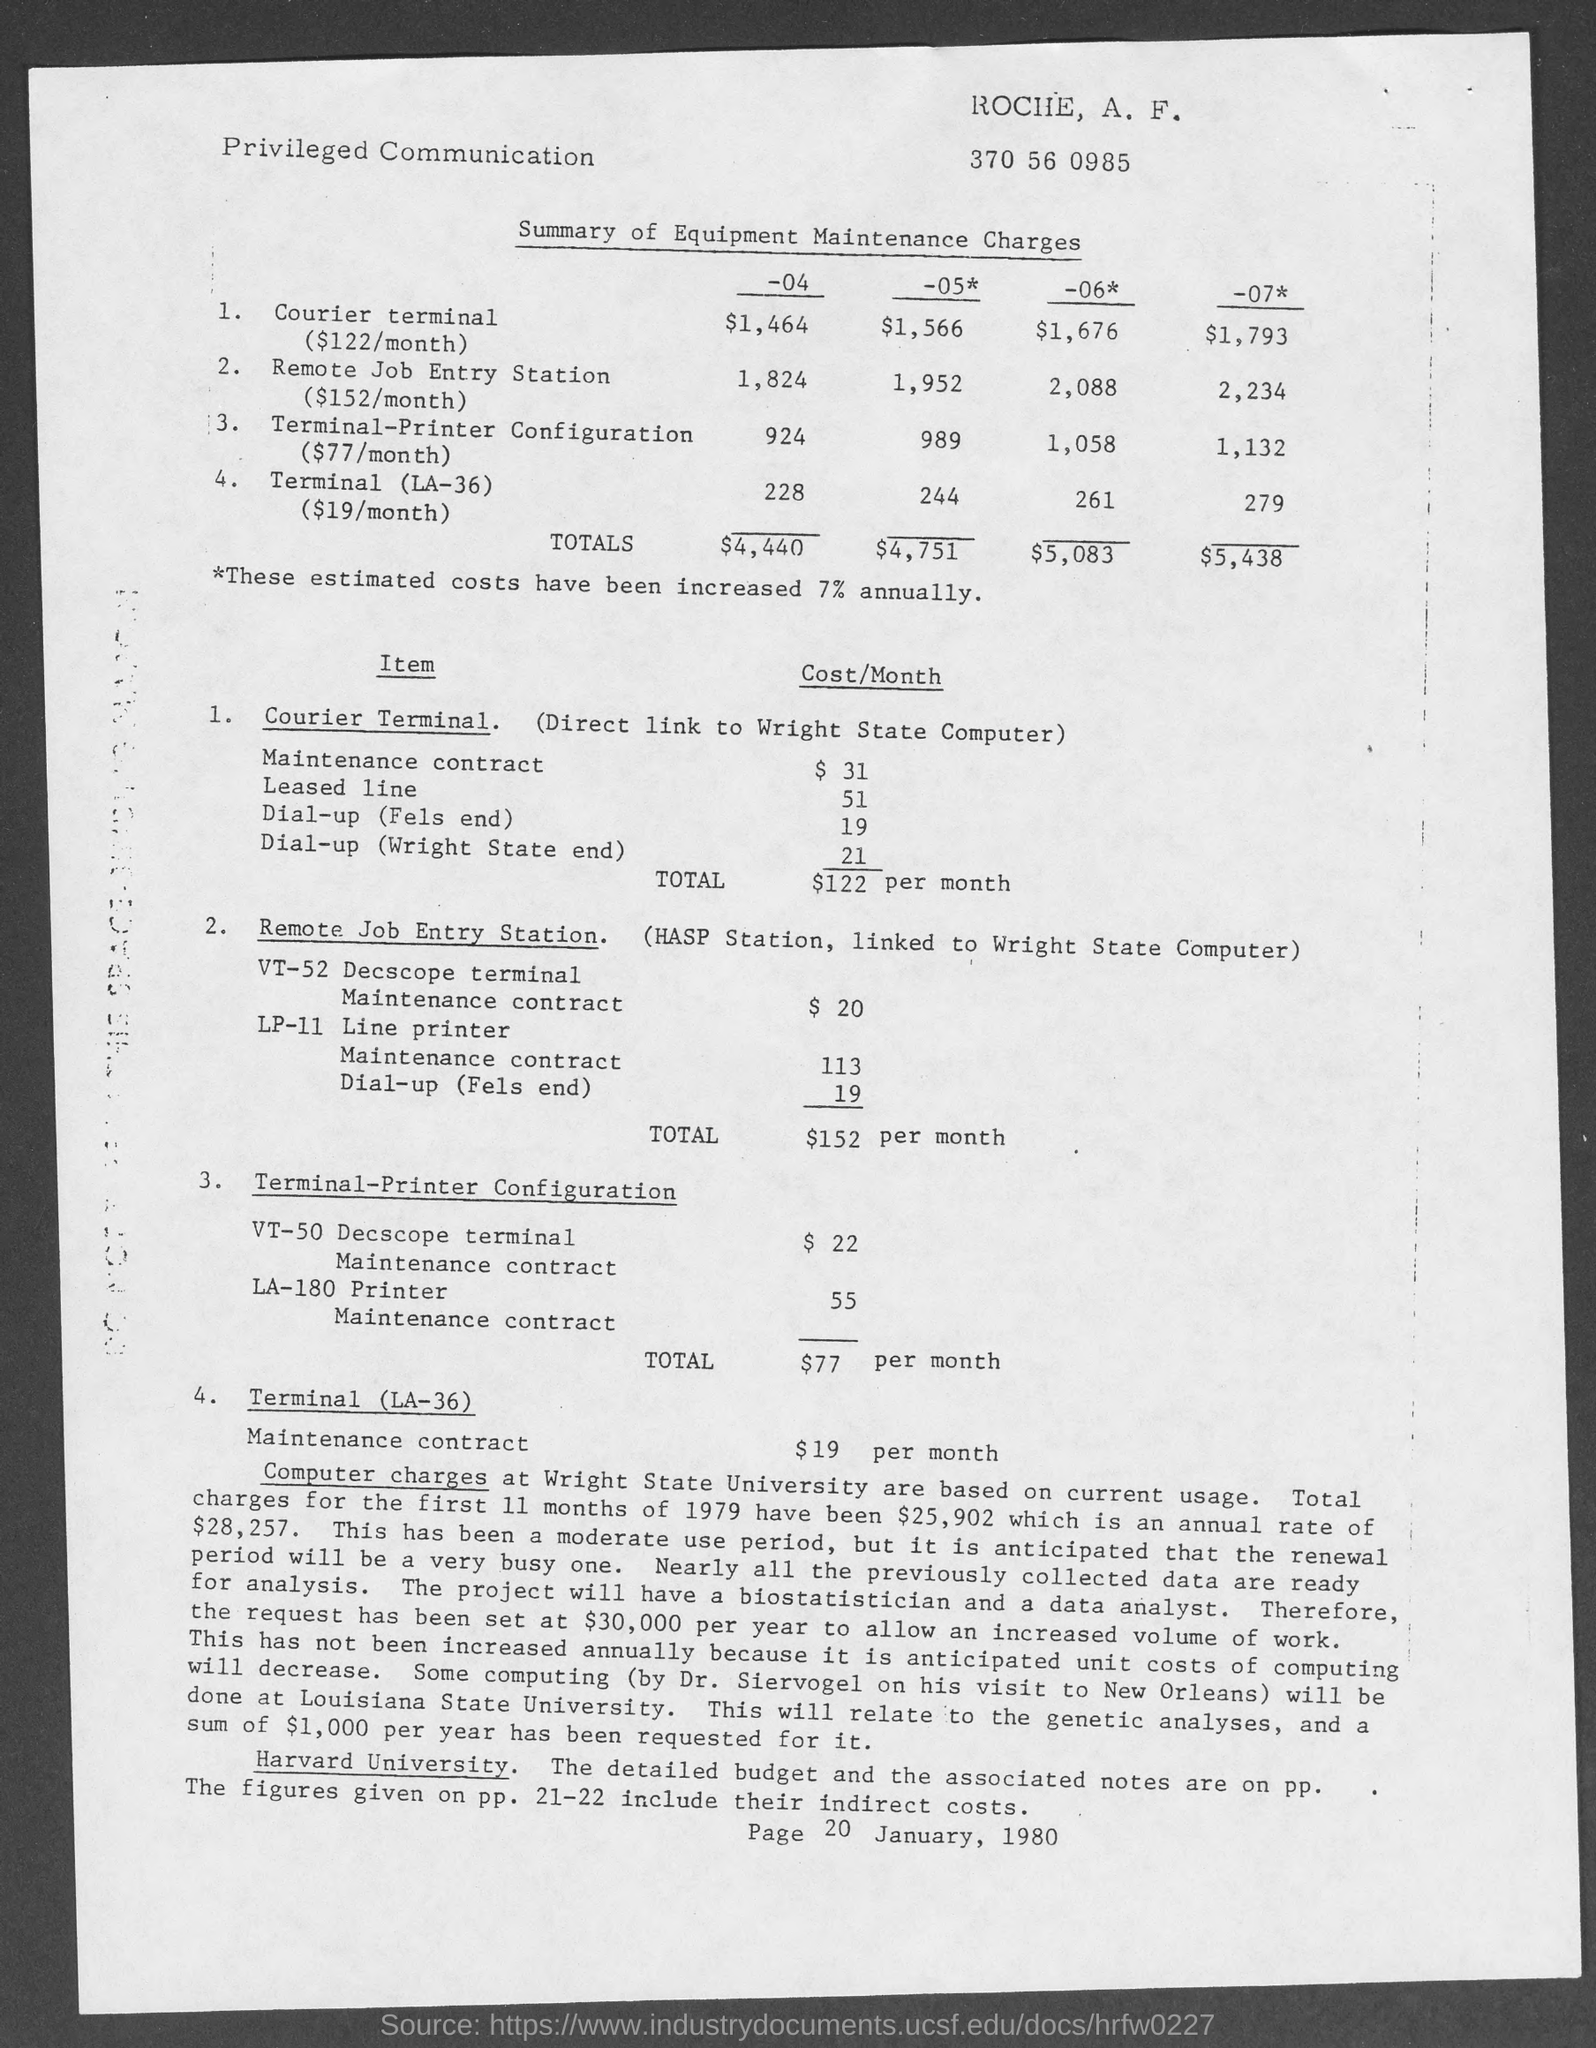What is the TOTAL Cost/Month of "courier terminal"?
Offer a very short reply. $122 per month. What is the MAINTENANCE CONTRACT Cost/Month of "courier terminal"?
Offer a terse response. $ 31. What is the TOTAL Cost/Month of "Remote Job Entry Station"?
Offer a terse response. $152. What is "VT-52 Decscope terminal Maintenance contract" Cost/Month for "Remote Job Entry Station"?
Provide a succinct answer. $ 20. What is "VT-52 Decscope terminal Maintenance contract" Cost/Month for "Terminal-Printer Configuration"?
Provide a succinct answer. $ 22. What is the TOTAL Cost/Month for "Terminal-Printer Configuration"?
Provide a succinct answer. $77 per month. Mention the page number given at the end of the page?
Provide a succinct answer. 20. What is the TOTAL Cost/Month of "Terminal-(LA-36)"?
Provide a short and direct response. $19. What is "LA-180 Printer Maintenance contract" Cost/Month for "Terminal-Printer Configuration"?
Your answer should be very brief. 55. What type of "communication" is this?
Keep it short and to the point. Privileged communication. 